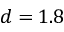<formula> <loc_0><loc_0><loc_500><loc_500>d = 1 . 8</formula> 